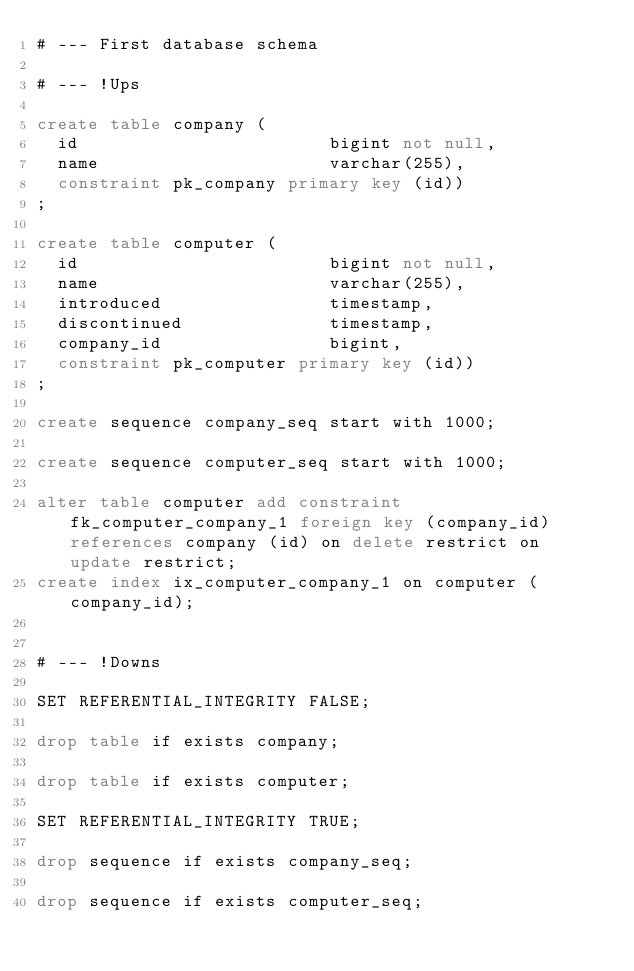<code> <loc_0><loc_0><loc_500><loc_500><_SQL_># --- First database schema

# --- !Ups

create table company (
  id                        bigint not null,
  name                      varchar(255),
  constraint pk_company primary key (id))
;

create table computer (
  id                        bigint not null,
  name                      varchar(255),
  introduced                timestamp,
  discontinued              timestamp,
  company_id                bigint,
  constraint pk_computer primary key (id))
;

create sequence company_seq start with 1000;

create sequence computer_seq start with 1000;

alter table computer add constraint fk_computer_company_1 foreign key (company_id) references company (id) on delete restrict on update restrict;
create index ix_computer_company_1 on computer (company_id);


# --- !Downs

SET REFERENTIAL_INTEGRITY FALSE;

drop table if exists company;

drop table if exists computer;

SET REFERENTIAL_INTEGRITY TRUE;

drop sequence if exists company_seq;

drop sequence if exists computer_seq;

</code> 